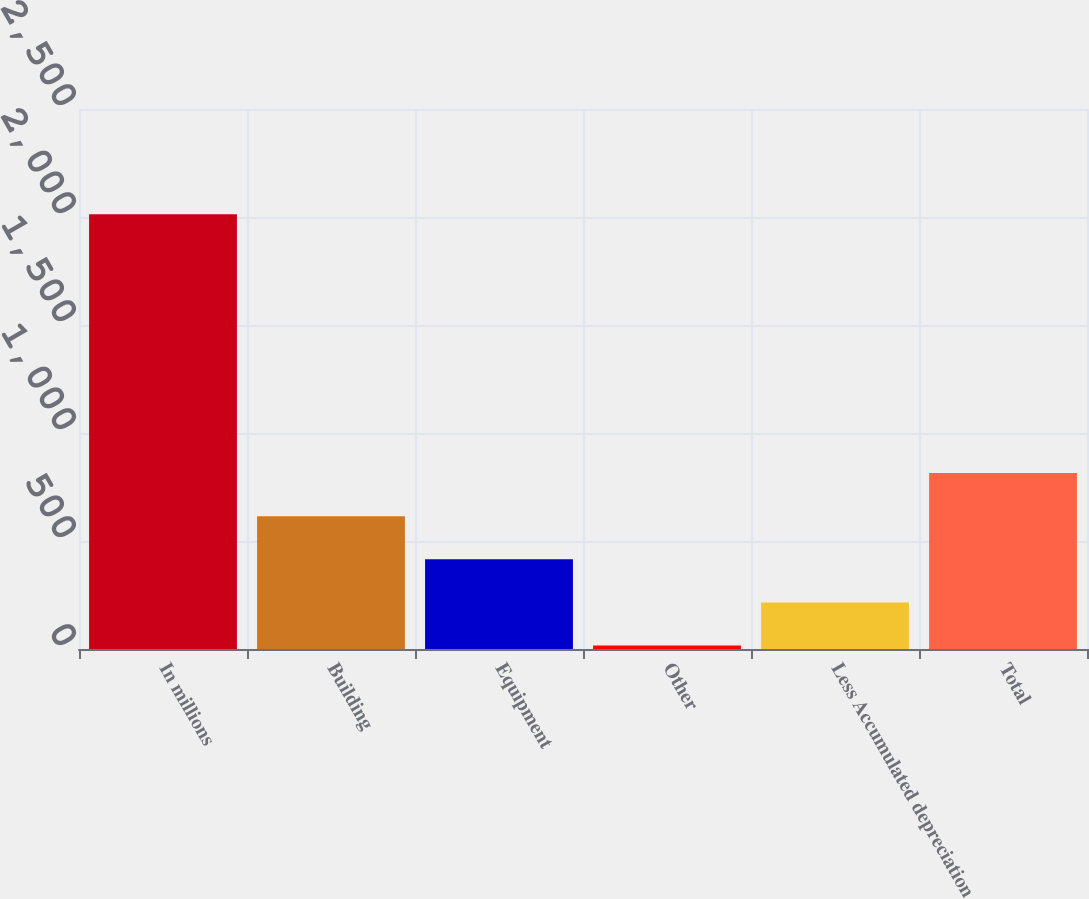Convert chart. <chart><loc_0><loc_0><loc_500><loc_500><bar_chart><fcel>In millions<fcel>Building<fcel>Equipment<fcel>Other<fcel>Less Accumulated depreciation<fcel>Total<nl><fcel>2013<fcel>615.1<fcel>415.4<fcel>16<fcel>215.7<fcel>814.8<nl></chart> 